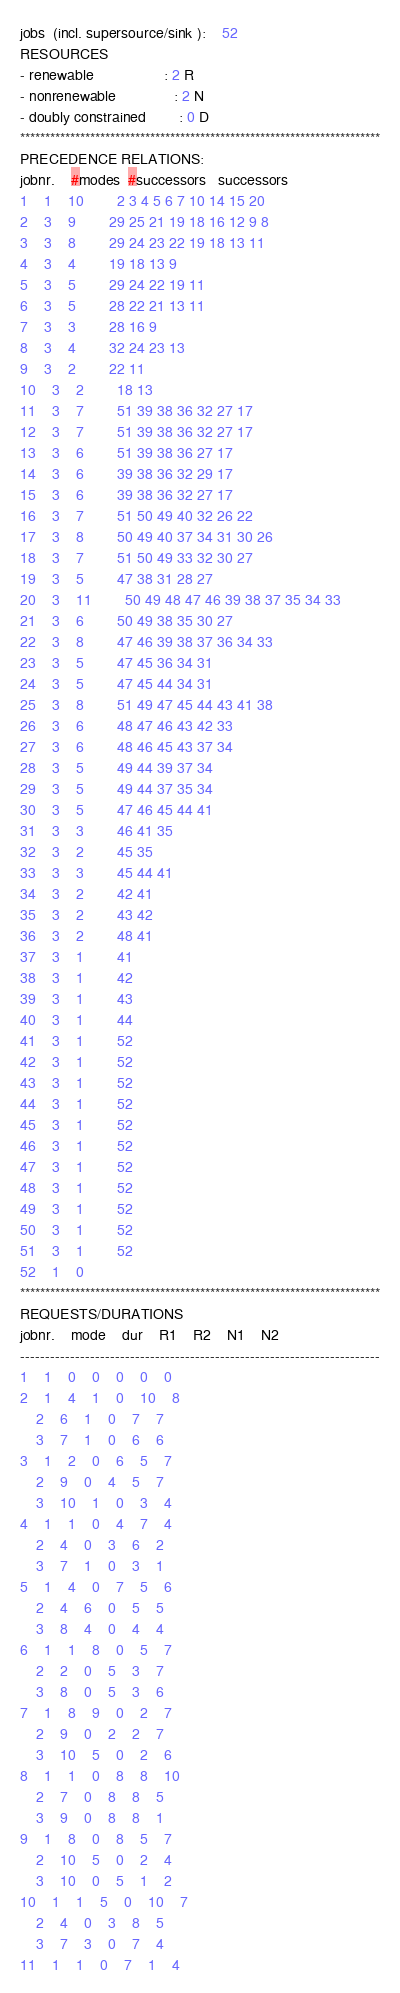Convert code to text. <code><loc_0><loc_0><loc_500><loc_500><_ObjectiveC_>jobs  (incl. supersource/sink ):	52
RESOURCES
- renewable                 : 2 R
- nonrenewable              : 2 N
- doubly constrained        : 0 D
************************************************************************
PRECEDENCE RELATIONS:
jobnr.    #modes  #successors   successors
1	1	10		2 3 4 5 6 7 10 14 15 20 
2	3	9		29 25 21 19 18 16 12 9 8 
3	3	8		29 24 23 22 19 18 13 11 
4	3	4		19 18 13 9 
5	3	5		29 24 22 19 11 
6	3	5		28 22 21 13 11 
7	3	3		28 16 9 
8	3	4		32 24 23 13 
9	3	2		22 11 
10	3	2		18 13 
11	3	7		51 39 38 36 32 27 17 
12	3	7		51 39 38 36 32 27 17 
13	3	6		51 39 38 36 27 17 
14	3	6		39 38 36 32 29 17 
15	3	6		39 38 36 32 27 17 
16	3	7		51 50 49 40 32 26 22 
17	3	8		50 49 40 37 34 31 30 26 
18	3	7		51 50 49 33 32 30 27 
19	3	5		47 38 31 28 27 
20	3	11		50 49 48 47 46 39 38 37 35 34 33 
21	3	6		50 49 38 35 30 27 
22	3	8		47 46 39 38 37 36 34 33 
23	3	5		47 45 36 34 31 
24	3	5		47 45 44 34 31 
25	3	8		51 49 47 45 44 43 41 38 
26	3	6		48 47 46 43 42 33 
27	3	6		48 46 45 43 37 34 
28	3	5		49 44 39 37 34 
29	3	5		49 44 37 35 34 
30	3	5		47 46 45 44 41 
31	3	3		46 41 35 
32	3	2		45 35 
33	3	3		45 44 41 
34	3	2		42 41 
35	3	2		43 42 
36	3	2		48 41 
37	3	1		41 
38	3	1		42 
39	3	1		43 
40	3	1		44 
41	3	1		52 
42	3	1		52 
43	3	1		52 
44	3	1		52 
45	3	1		52 
46	3	1		52 
47	3	1		52 
48	3	1		52 
49	3	1		52 
50	3	1		52 
51	3	1		52 
52	1	0		
************************************************************************
REQUESTS/DURATIONS
jobnr.	mode	dur	R1	R2	N1	N2	
------------------------------------------------------------------------
1	1	0	0	0	0	0	
2	1	4	1	0	10	8	
	2	6	1	0	7	7	
	3	7	1	0	6	6	
3	1	2	0	6	5	7	
	2	9	0	4	5	7	
	3	10	1	0	3	4	
4	1	1	0	4	7	4	
	2	4	0	3	6	2	
	3	7	1	0	3	1	
5	1	4	0	7	5	6	
	2	4	6	0	5	5	
	3	8	4	0	4	4	
6	1	1	8	0	5	7	
	2	2	0	5	3	7	
	3	8	0	5	3	6	
7	1	8	9	0	2	7	
	2	9	0	2	2	7	
	3	10	5	0	2	6	
8	1	1	0	8	8	10	
	2	7	0	8	8	5	
	3	9	0	8	8	1	
9	1	8	0	8	5	7	
	2	10	5	0	2	4	
	3	10	0	5	1	2	
10	1	1	5	0	10	7	
	2	4	0	3	8	5	
	3	7	3	0	7	4	
11	1	1	0	7	1	4	</code> 